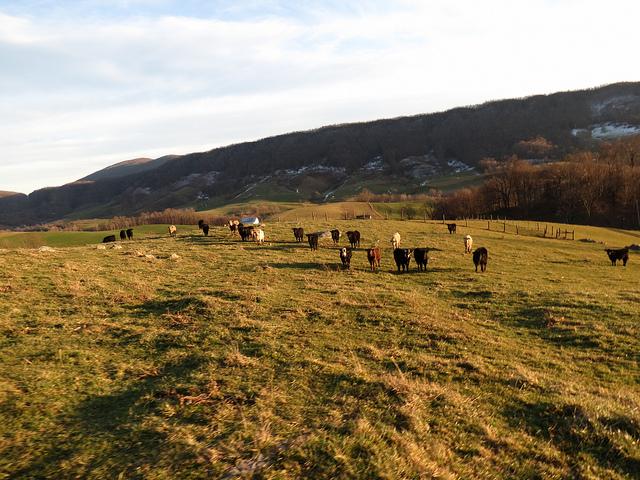What is in the background?
Be succinct. Mountain. What time of year is this?
Give a very brief answer. Spring. What color is the cow?
Write a very short answer. Brown. How many horses are there?
Keep it brief. 0. Are any living creatures present?
Be succinct. Yes. What type of animal is in the field?
Short answer required. Cows. Is it dusk?
Quick response, please. No. 